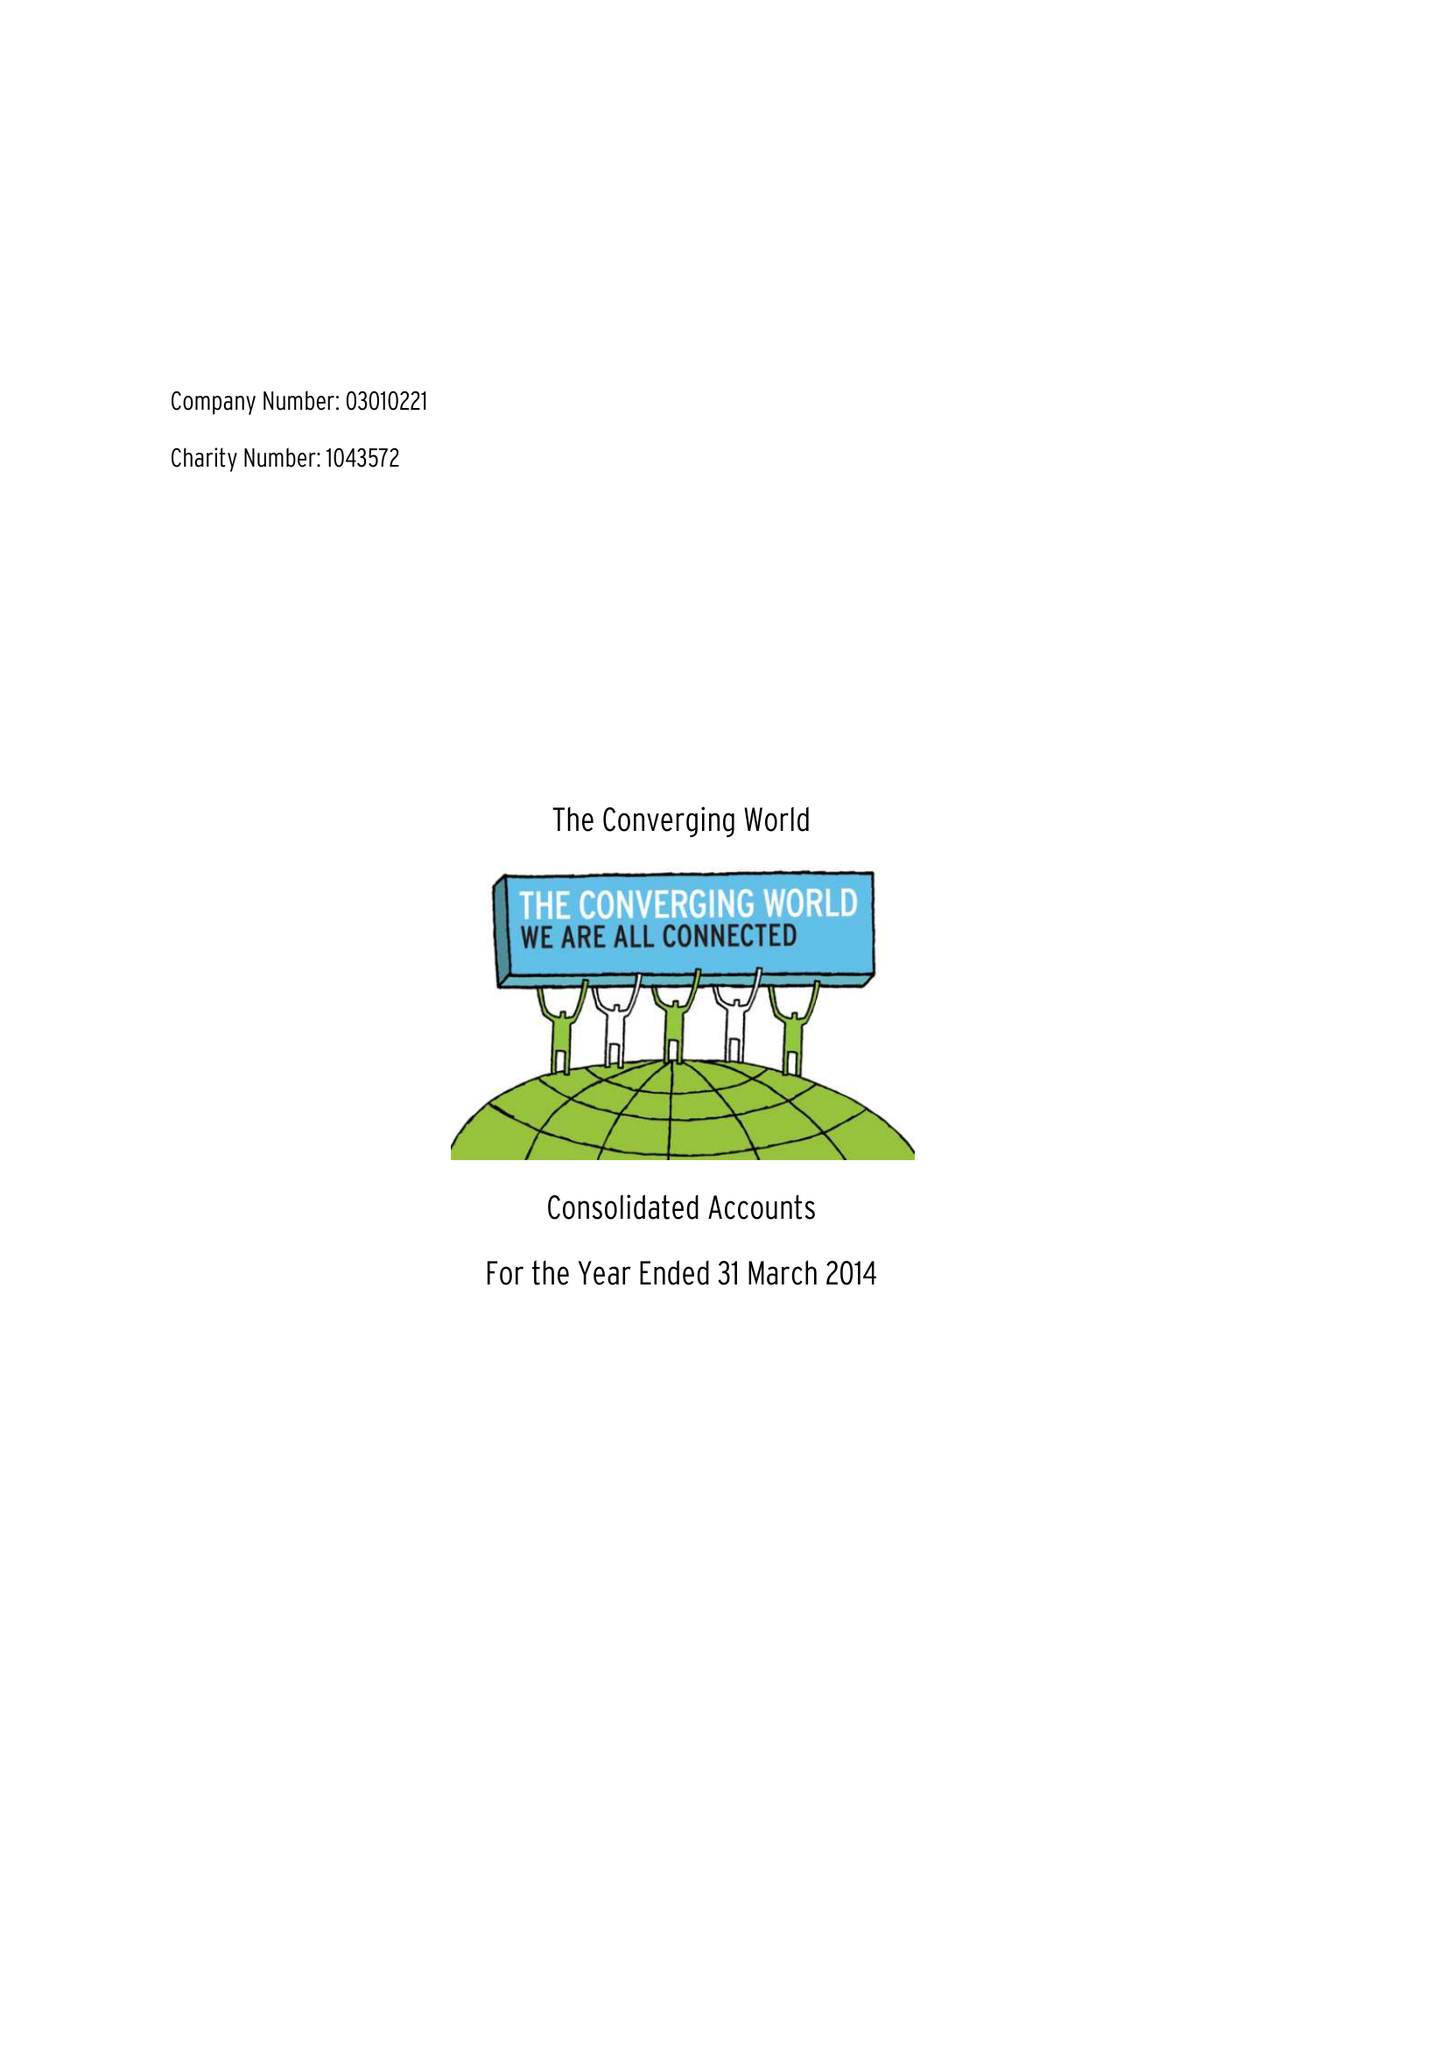What is the value for the income_annually_in_british_pounds?
Answer the question using a single word or phrase. 360240.00 